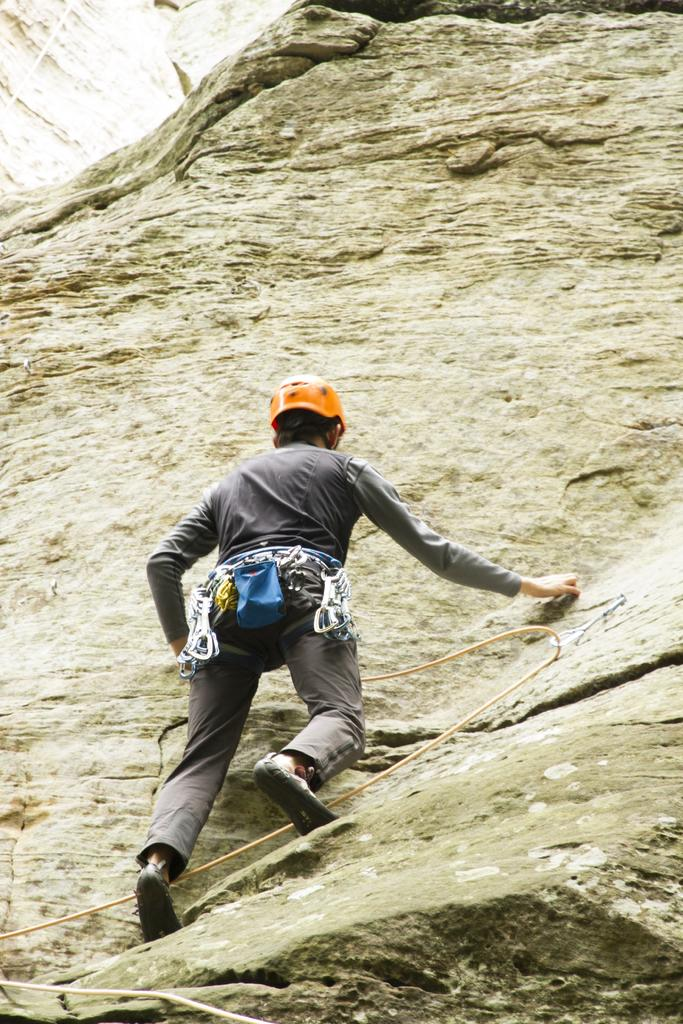What is the main subject of the image? There is a person in the image. What is the person doing in the image? The person is climbing a hill. How is the person assisted in climbing the hill? The person is using ropes for assistance. What safety gear is the person wearing? The person is wearing a helmet. What is the profit made by the person in the image? There is no mention of profit or any financial aspect in the image. The focus is on the person climbing a hill with ropes and wearing a helmet. 